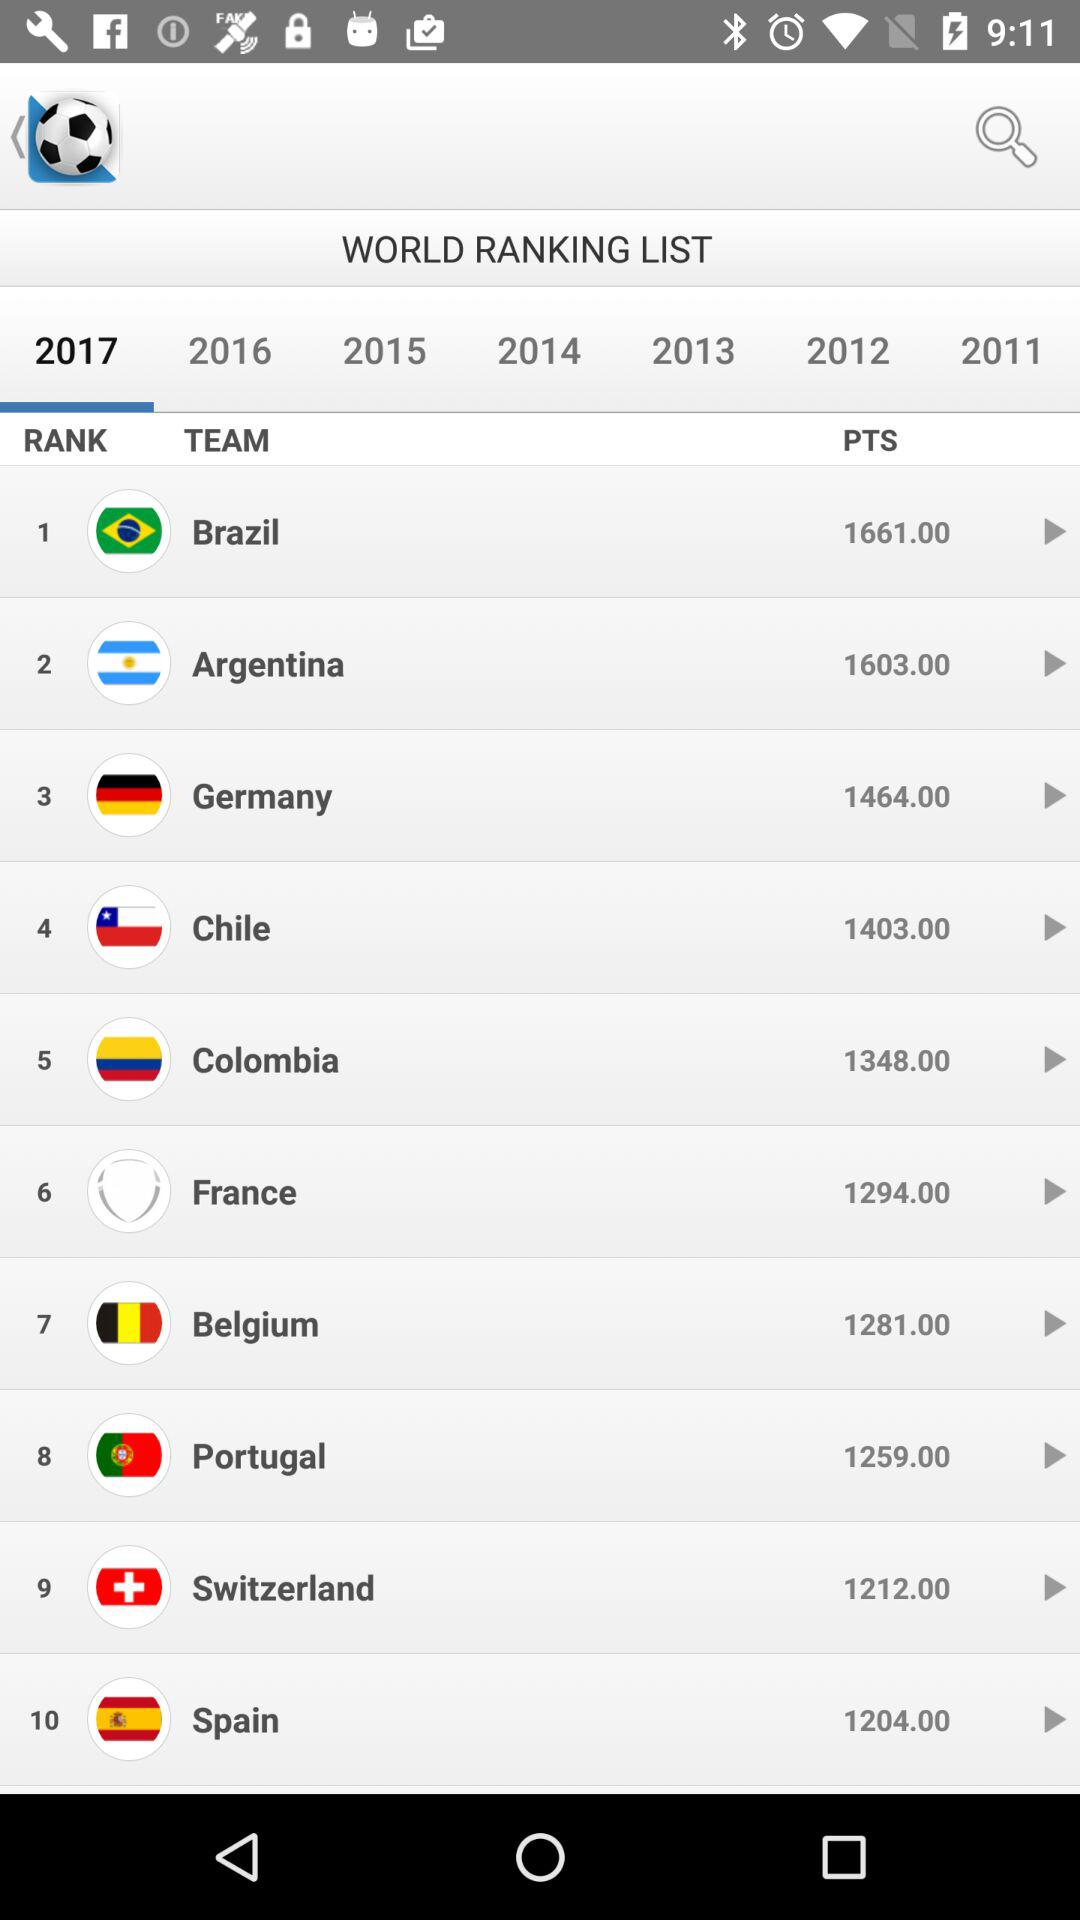What is the rank of team "France"? The rank is 6. 